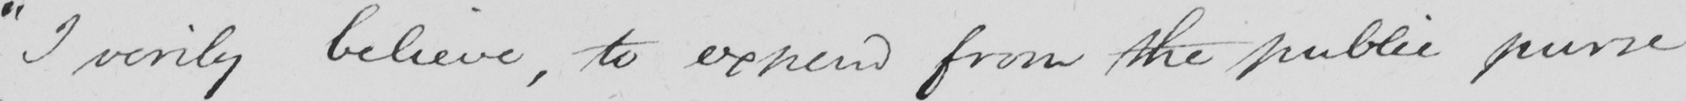Transcribe the text shown in this historical manuscript line. " I verily believe , to expend from the public purse 